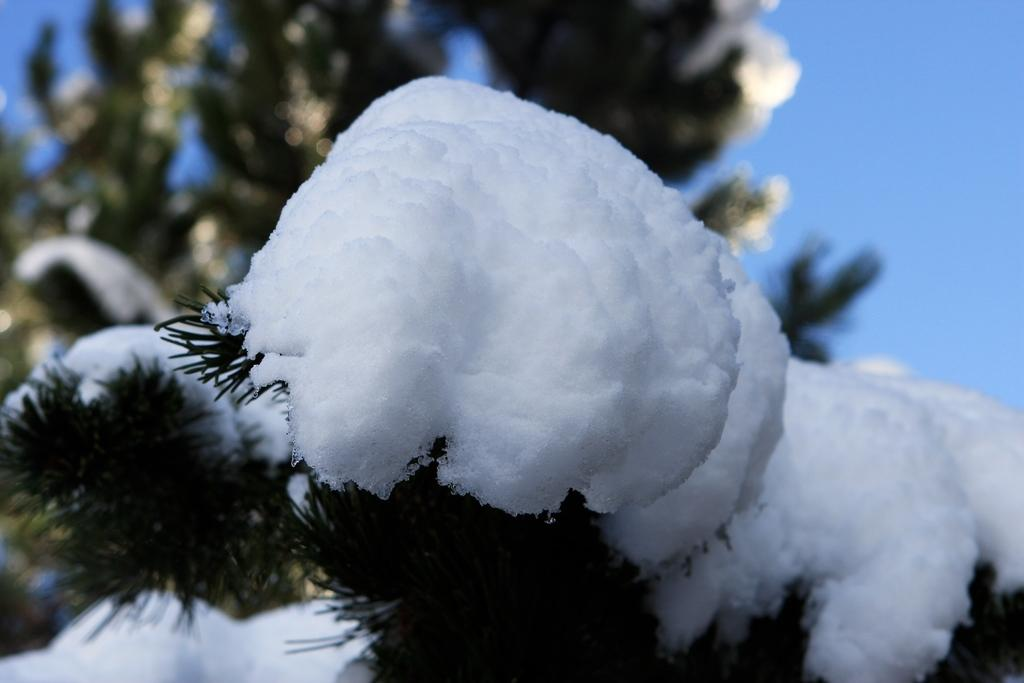What is covering the leaves in the image? The leaves are covered with snow in the image. What else in the image is covered with snow? There is a tree covered with snow in the background of the image. What color is the background of the image? The background of the image is blue. What type of bloodstain can be seen on the leaves in the image? There is no bloodstain present in the image; the leaves are covered with snow. 